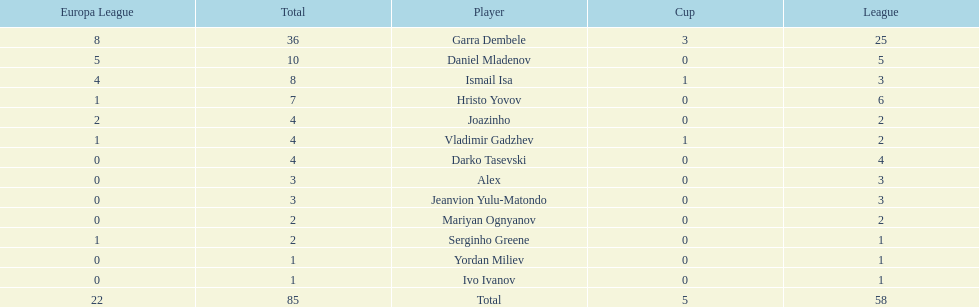What league is 2? 2, 2, 2. Which cup is less than 1? 0, 0. Which total is 2? 2. Who is the player? Mariyan Ognyanov. 